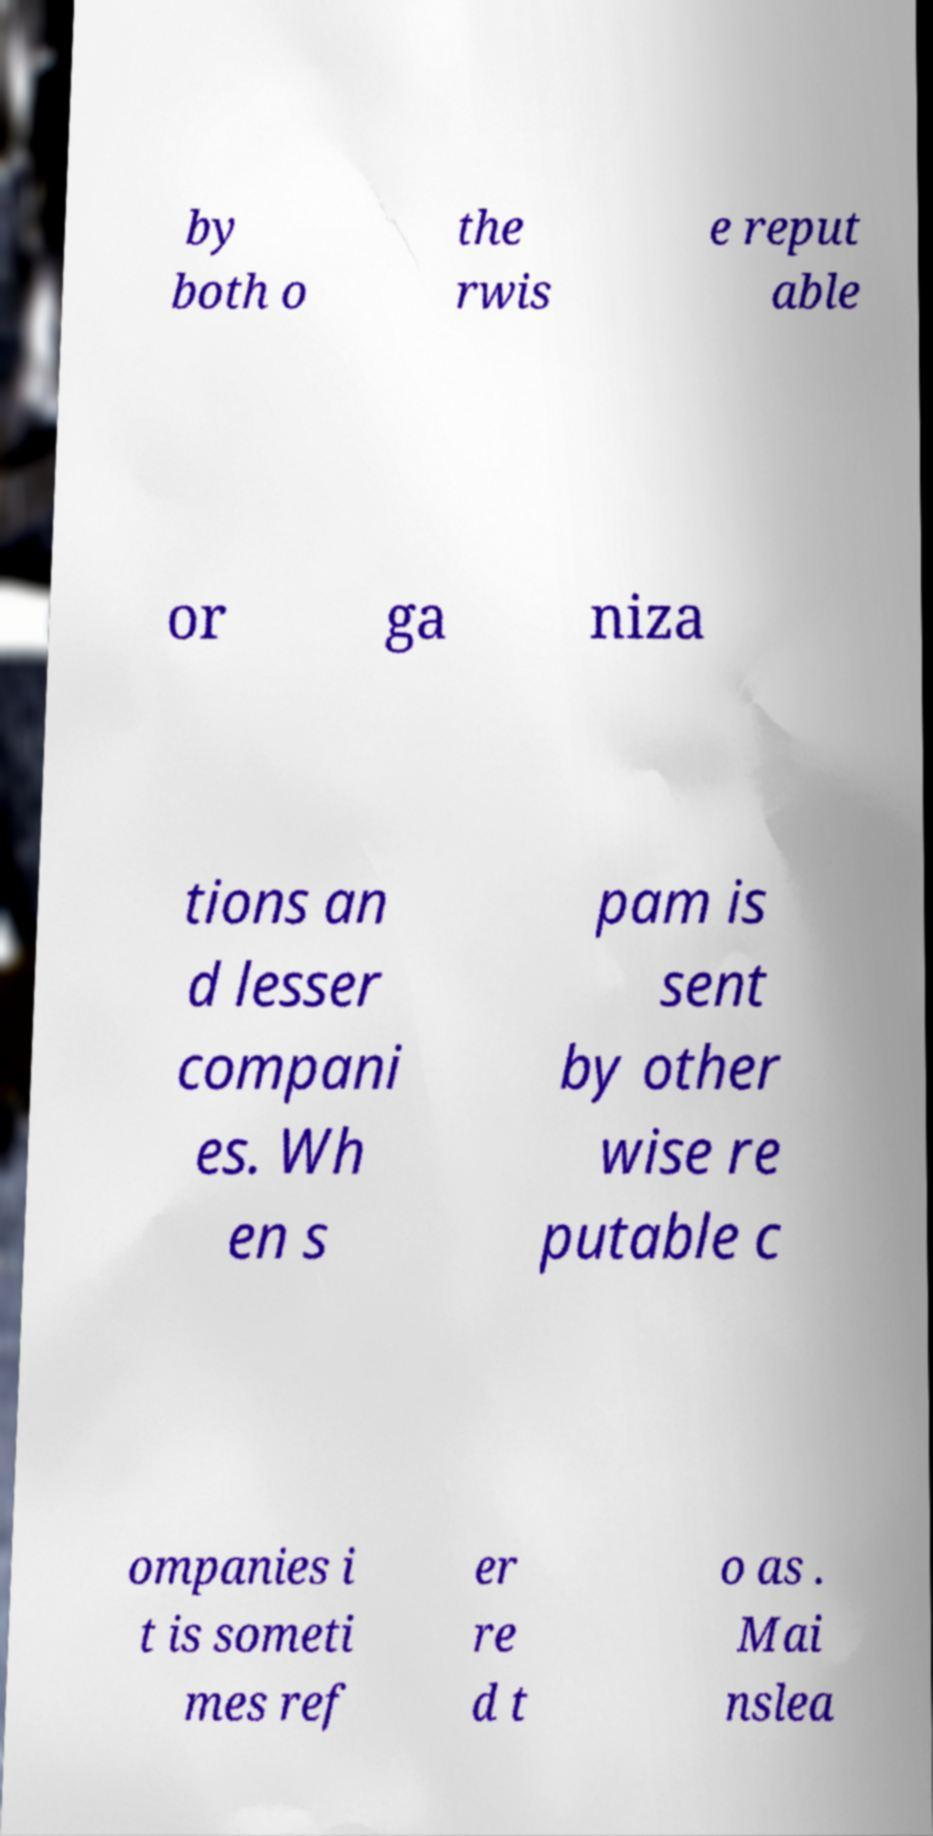I need the written content from this picture converted into text. Can you do that? by both o the rwis e reput able or ga niza tions an d lesser compani es. Wh en s pam is sent by other wise re putable c ompanies i t is someti mes ref er re d t o as . Mai nslea 